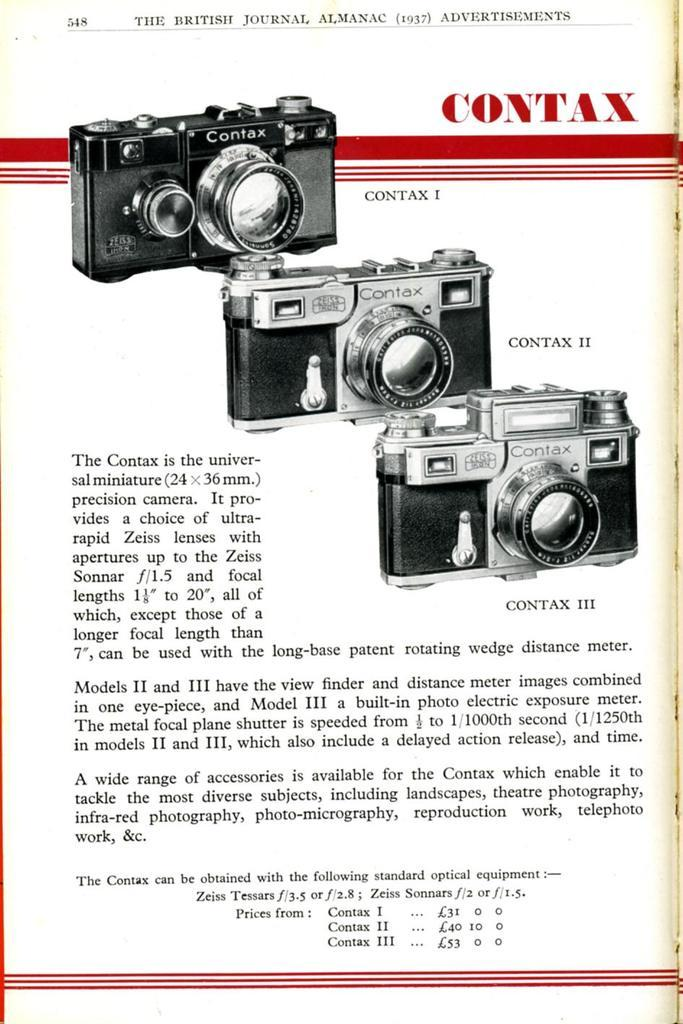What object is present in the image that is commonly used for reading? There is a book in the image that is commonly used for reading. What can be found on the book in the image? Text is written on the book in the image. What type of images are present in the image? There are images of cameras in the image. What type of polish is being applied to the cameras in the image? There is no polish being applied to the cameras in the image; the image only shows images of cameras. What type of chain is connecting the book to the cameras in the image? There is no chain connecting the book to the cameras in the image; the objects are separate and not physically connected. 